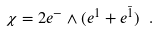<formula> <loc_0><loc_0><loc_500><loc_500>\chi = 2 e ^ { - } \wedge ( e ^ { 1 } + e ^ { \bar { 1 } } ) \text { } .</formula> 